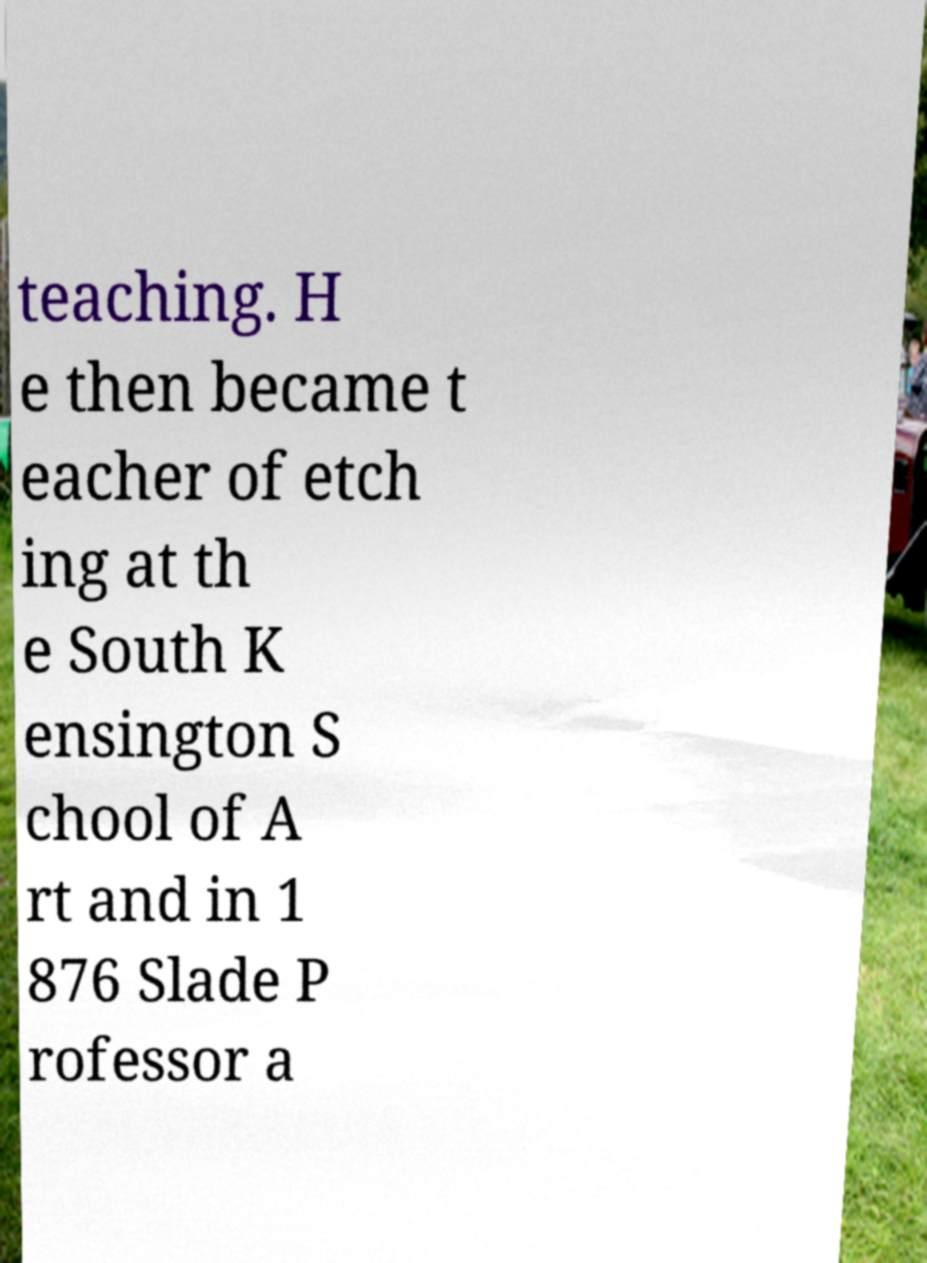Can you accurately transcribe the text from the provided image for me? teaching. H e then became t eacher of etch ing at th e South K ensington S chool of A rt and in 1 876 Slade P rofessor a 